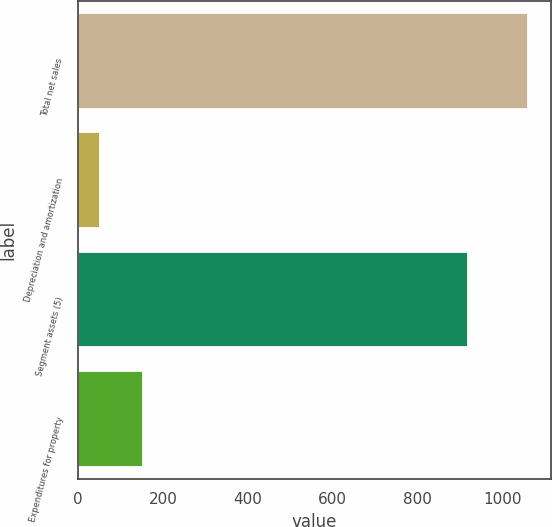Convert chart to OTSL. <chart><loc_0><loc_0><loc_500><loc_500><bar_chart><fcel>Total net sales<fcel>Depreciation and amortization<fcel>Segment assets (5)<fcel>Expenditures for property<nl><fcel>1061<fcel>52<fcel>919<fcel>152.9<nl></chart> 